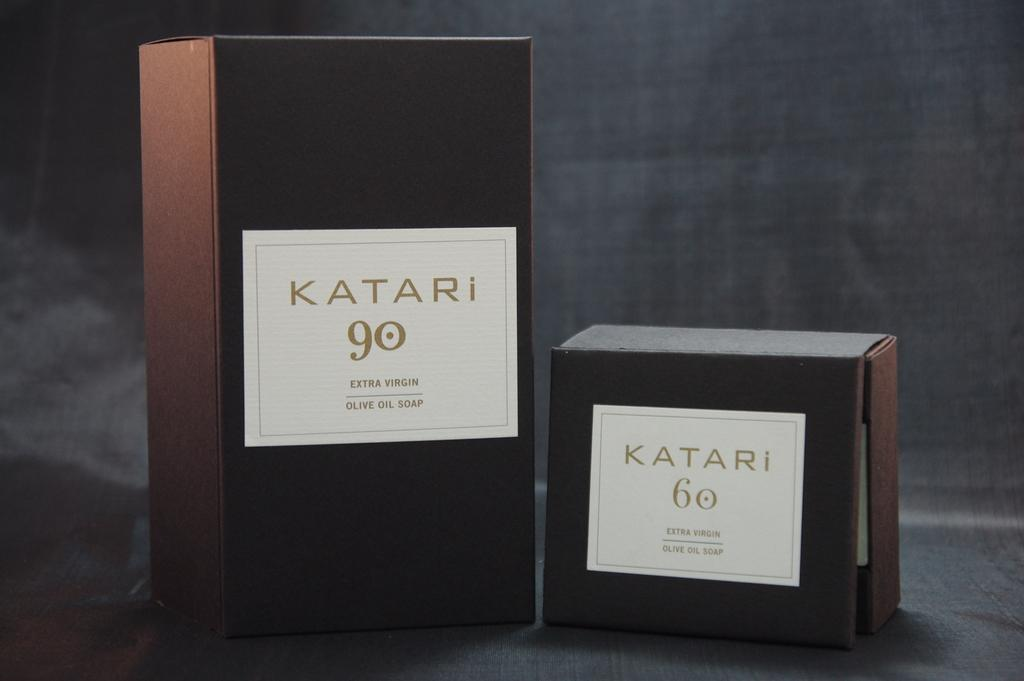How many boxes are visible in the image? There are two boxes in the image. Where are the boxes located? The boxes are on a surface. What color are the labels on the boxes? The boxes have white color labels. What can be found on the boxes besides the labels? There is writing on the boxes. Is there a volcano erupting in the background of the image? There is no volcano present in the image. 